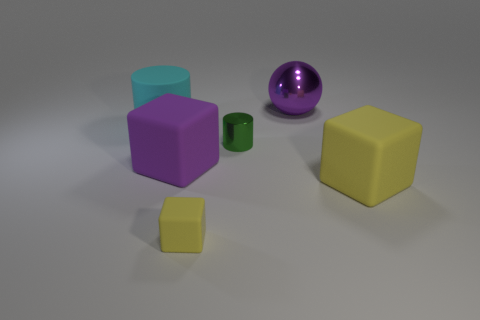Add 2 cubes. How many objects exist? 8 Subtract all balls. How many objects are left? 5 Add 3 tiny yellow rubber objects. How many tiny yellow rubber objects are left? 4 Add 4 yellow matte blocks. How many yellow matte blocks exist? 6 Subtract 0 gray blocks. How many objects are left? 6 Subtract all large balls. Subtract all large spheres. How many objects are left? 4 